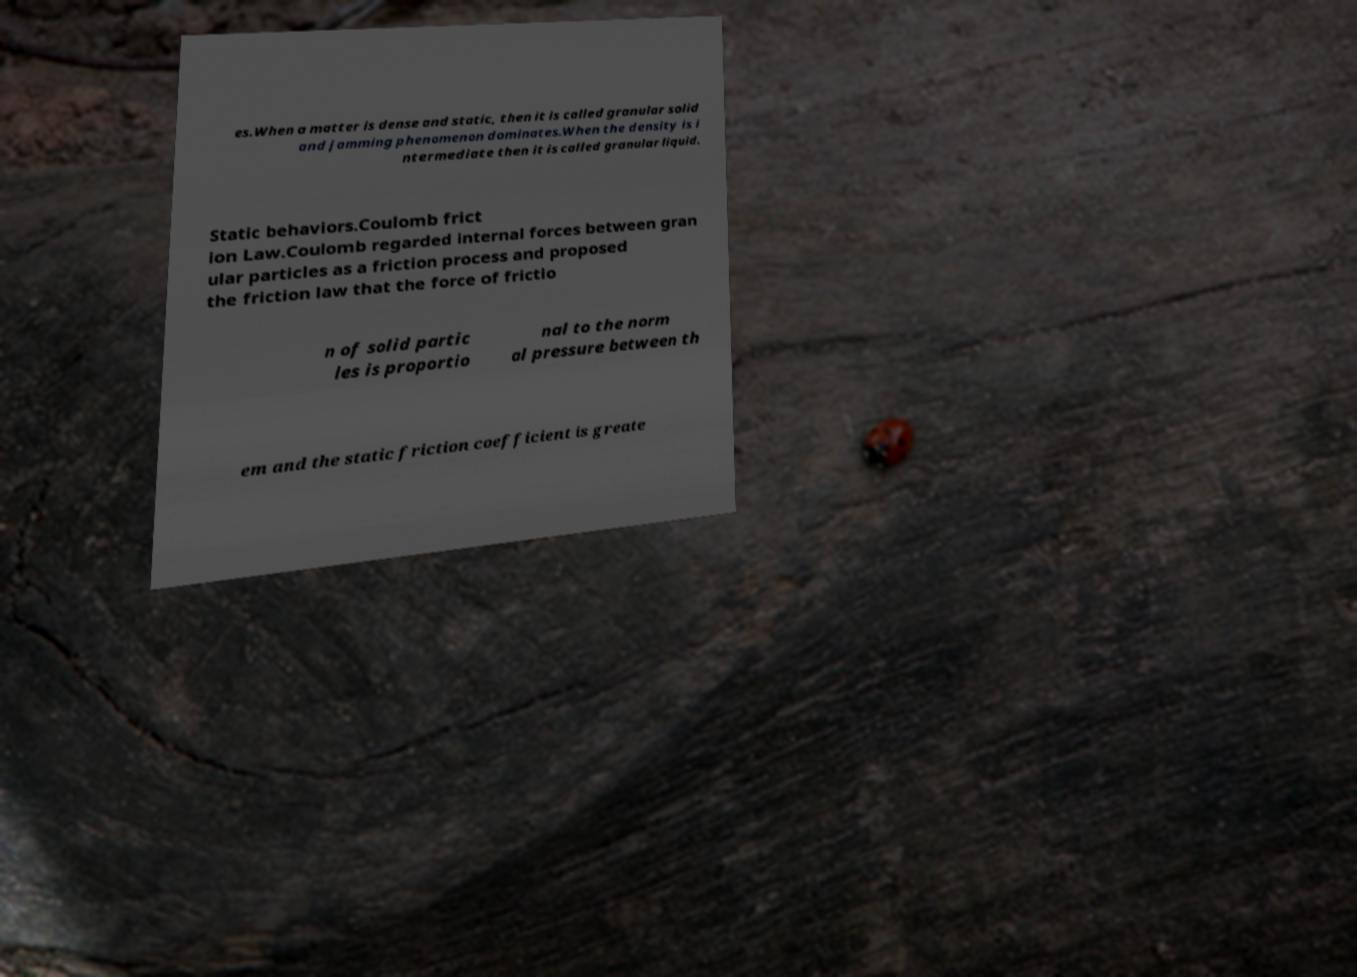Could you extract and type out the text from this image? es.When a matter is dense and static, then it is called granular solid and jamming phenomenon dominates.When the density is i ntermediate then it is called granular liquid. Static behaviors.Coulomb frict ion Law.Coulomb regarded internal forces between gran ular particles as a friction process and proposed the friction law that the force of frictio n of solid partic les is proportio nal to the norm al pressure between th em and the static friction coefficient is greate 